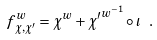<formula> <loc_0><loc_0><loc_500><loc_500>f _ { \chi , \chi ^ { \prime } } ^ { w } = \chi ^ { w } + { \chi ^ { \prime } } ^ { w ^ { - 1 } } \circ \iota \ .</formula> 